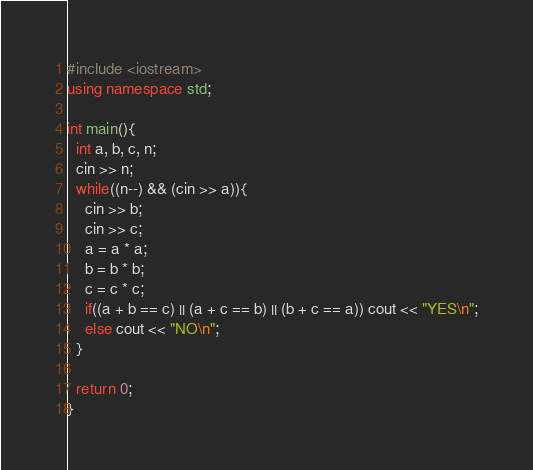Convert code to text. <code><loc_0><loc_0><loc_500><loc_500><_C++_>#include <iostream>
using namespace std;

int main(){
  int a, b, c, n;
  cin >> n;
  while((n--) && (cin >> a)){
    cin >> b;
    cin >> c;
    a = a * a;
    b = b * b;
    c = c * c;
    if((a + b == c) || (a + c == b) || (b + c == a)) cout << "YES\n";
    else cout << "NO\n";
  }

  return 0;
}</code> 